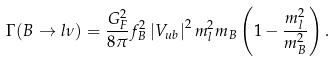<formula> <loc_0><loc_0><loc_500><loc_500>\Gamma ( B \to l \nu ) = \frac { G _ { F } ^ { 2 } } { 8 \pi } f _ { B } ^ { 2 } \left | V _ { u b } \right | ^ { 2 } m _ { l } ^ { 2 } m _ { B } \left ( 1 - \frac { m _ { l } ^ { 2 } } { m _ { B } ^ { 2 } } \right ) .</formula> 